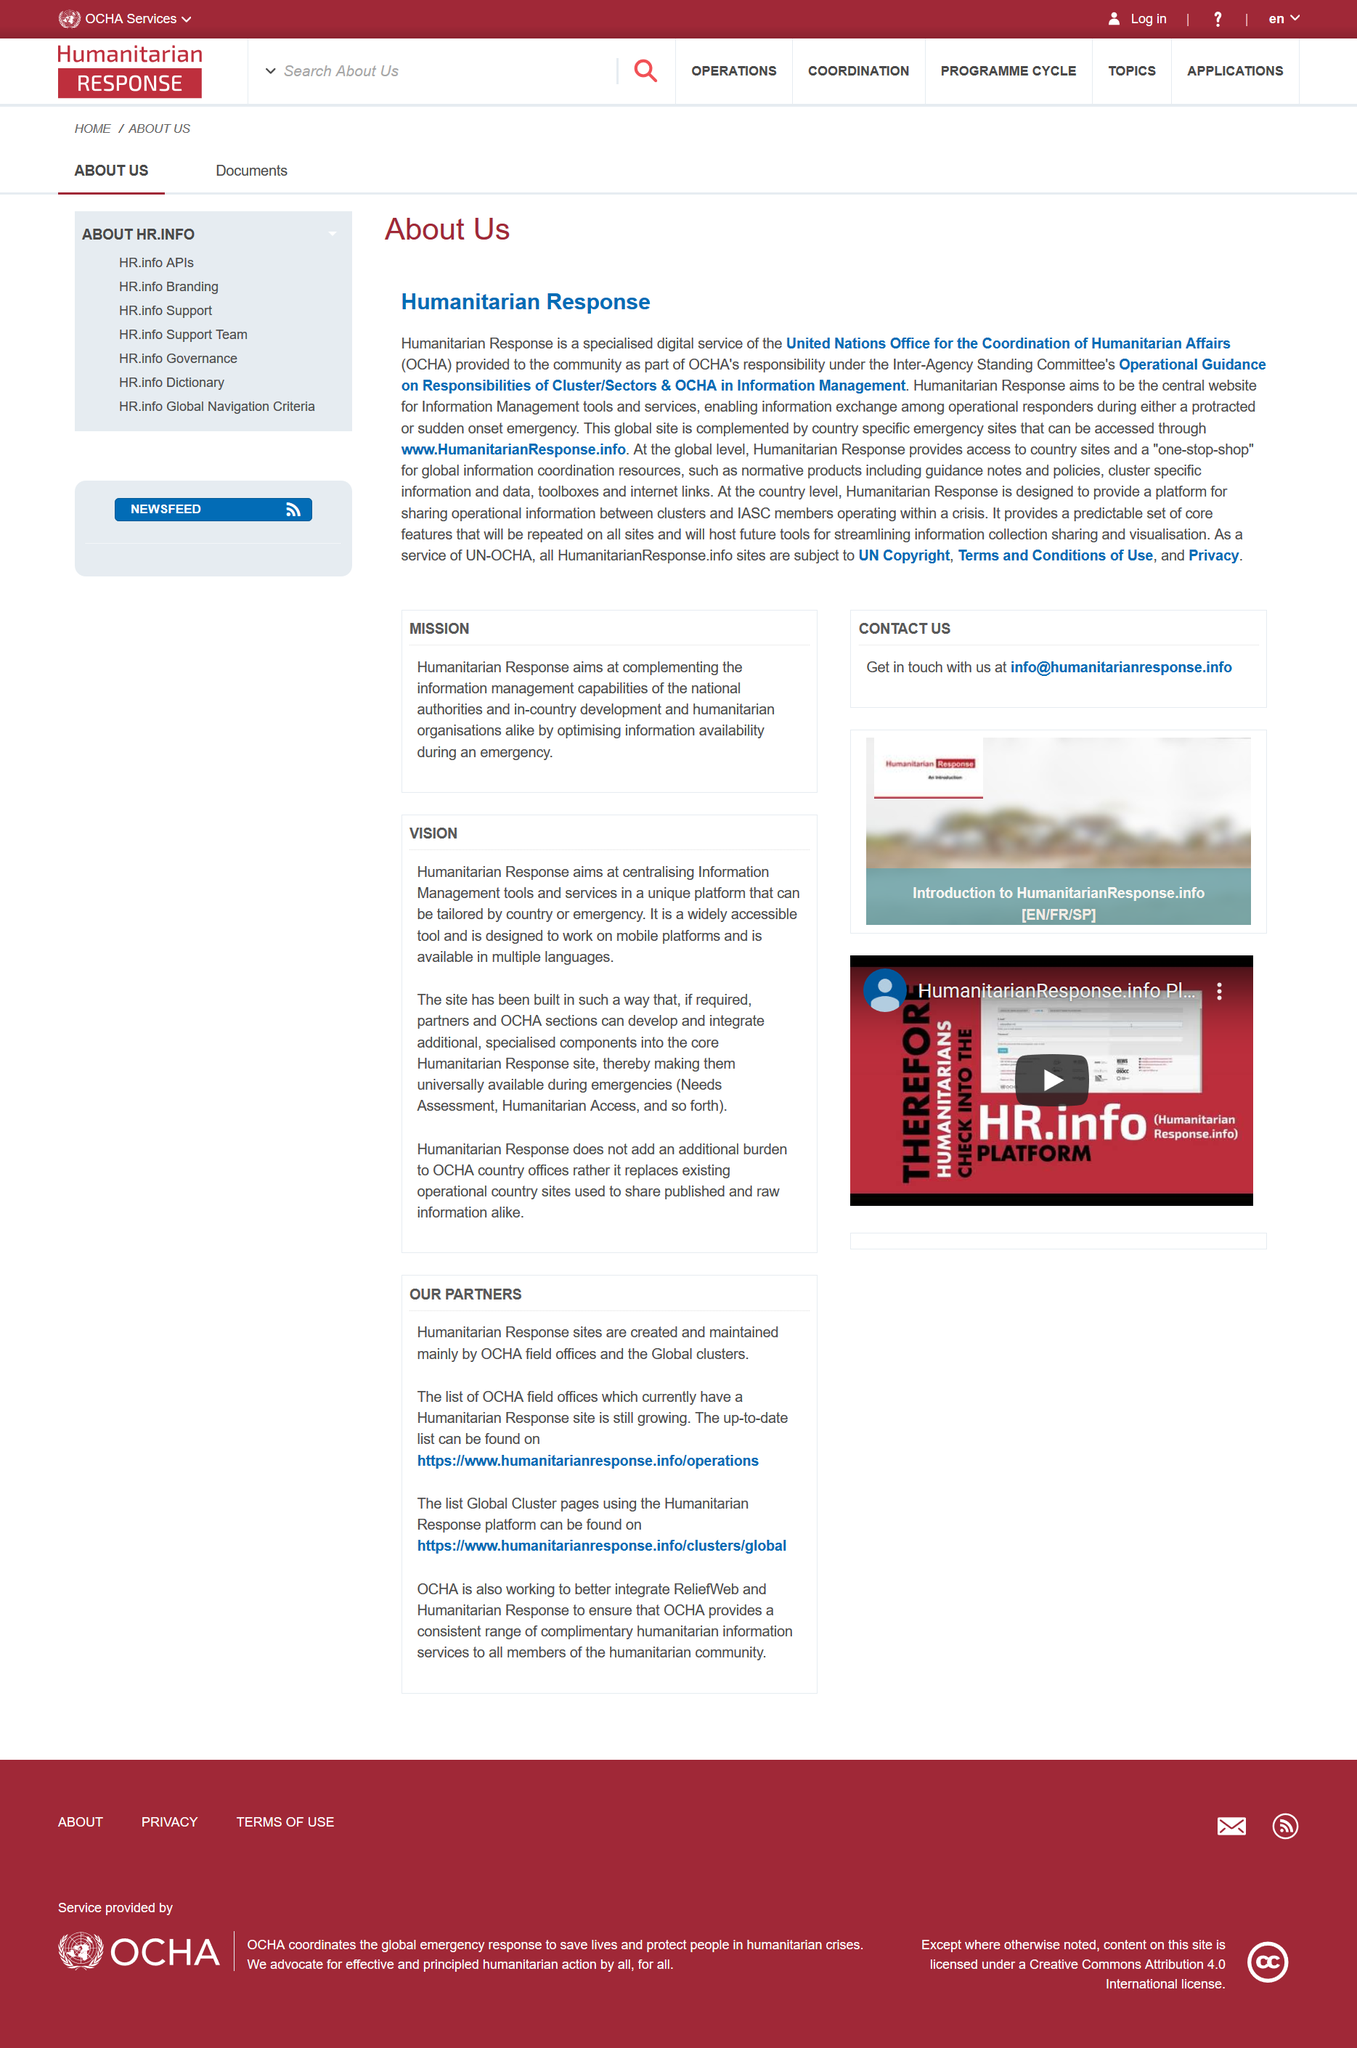Specify some key components in this picture. It is not stated on the document that a phone number is included. The e-mail address that one should use to contact the company is [info@humanitarianresponse.info](mailto:info@humanitarianresponse.info). The Office for the Coordination of Humanitarian Affairs (OCHA) is working to better integrate the ReliefWeb and Humanitarian Response platforms in order to improve the efficiency and effectiveness of its operations. In the event of an emergency, country-specific emergency sites can be accessed through the website www.HumanitarianResponse.info. There are 3 subheadings on the page. 